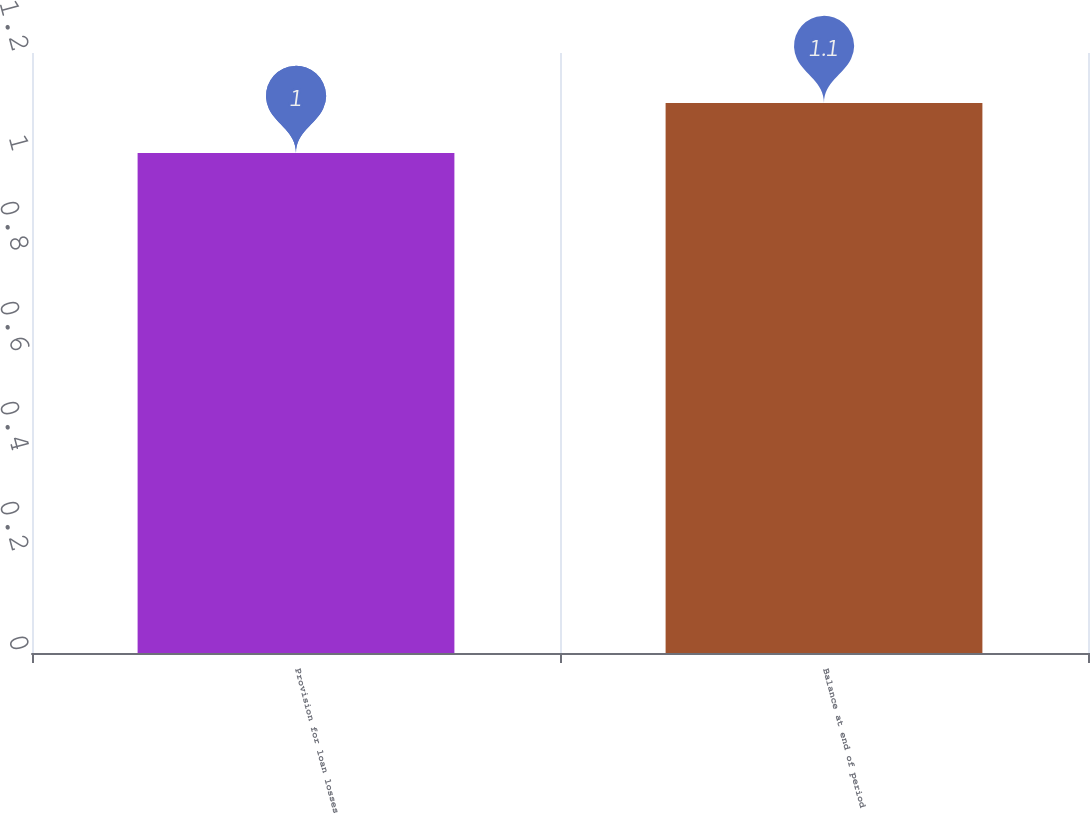<chart> <loc_0><loc_0><loc_500><loc_500><bar_chart><fcel>Provision for loan losses<fcel>Balance at end of period<nl><fcel>1<fcel>1.1<nl></chart> 